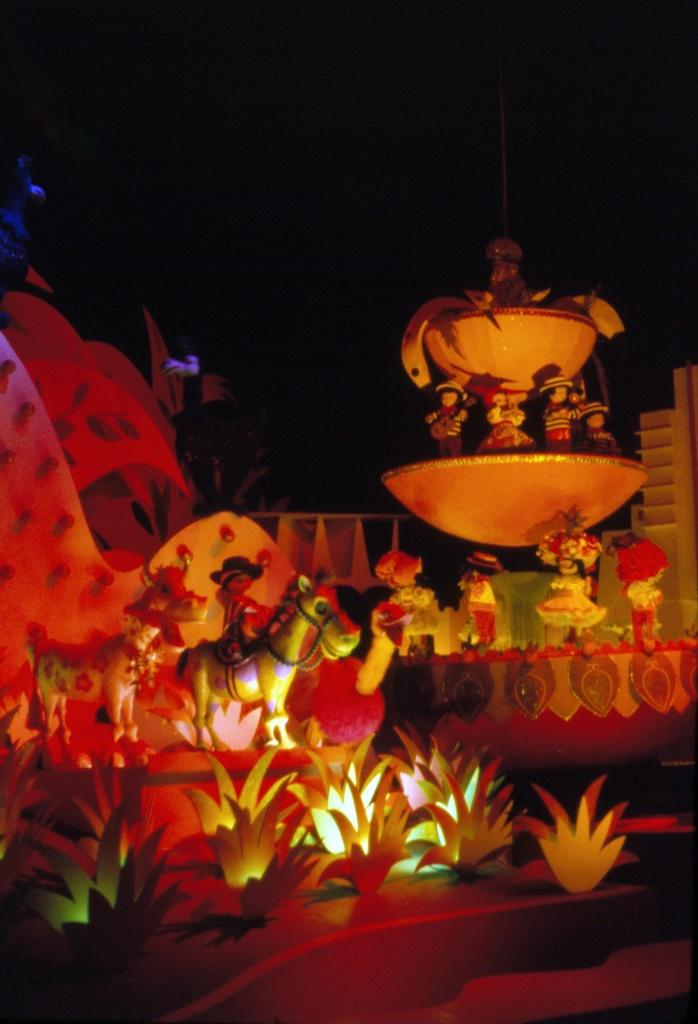What structure is located on the right side of the image? There is a fountain on the right side of the image. What can be seen on the left side of the image? There are toys on the left side of the image. What is visible in the background of the image? The sky is visible in the background of the image. Where is the throne located in the image? There is no throne present in the image. Who is the uncle mentioned in the image? There is no mention of an uncle in the image. 